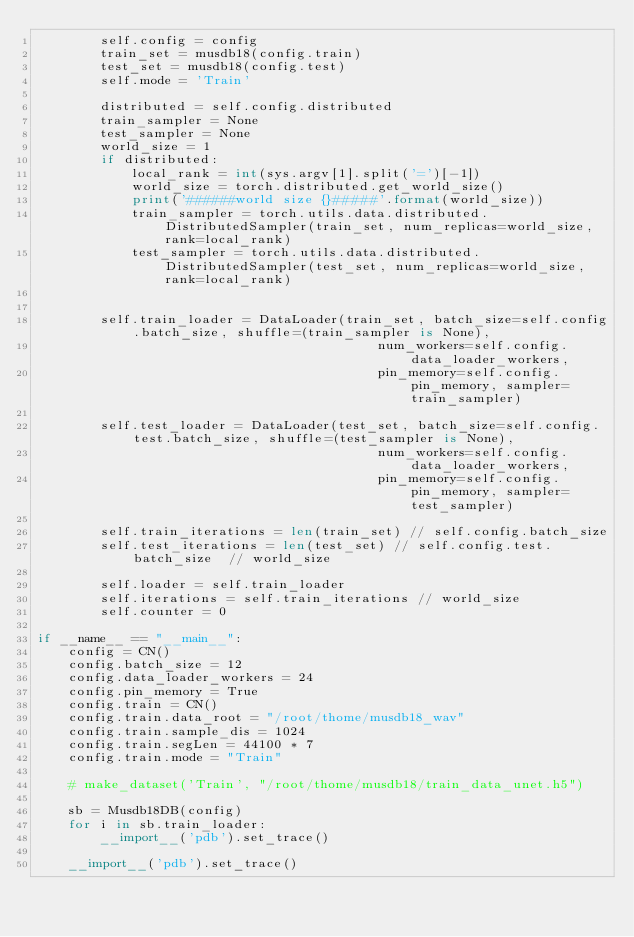Convert code to text. <code><loc_0><loc_0><loc_500><loc_500><_Python_>        self.config = config
        train_set = musdb18(config.train)
        test_set = musdb18(config.test)
        self.mode = 'Train'

        distributed = self.config.distributed
        train_sampler = None
        test_sampler = None
        world_size = 1
        if distributed:
            local_rank = int(sys.argv[1].split('=')[-1])
            world_size = torch.distributed.get_world_size()
            print('######world size {}#####'.format(world_size))
            train_sampler = torch.utils.data.distributed.DistributedSampler(train_set, num_replicas=world_size, rank=local_rank)
            test_sampler = torch.utils.data.distributed.DistributedSampler(test_set, num_replicas=world_size, rank=local_rank)


        self.train_loader = DataLoader(train_set, batch_size=self.config.batch_size, shuffle=(train_sampler is None),
                                           num_workers=self.config.data_loader_workers,
                                           pin_memory=self.config.pin_memory, sampler=train_sampler)

        self.test_loader = DataLoader(test_set, batch_size=self.config.test.batch_size, shuffle=(test_sampler is None),
                                           num_workers=self.config.data_loader_workers,
                                           pin_memory=self.config.pin_memory, sampler=test_sampler)

        self.train_iterations = len(train_set) // self.config.batch_size
        self.test_iterations = len(test_set) // self.config.test.batch_size  // world_size

        self.loader = self.train_loader
        self.iterations = self.train_iterations // world_size
        self.counter = 0

if __name__ == "__main__":
    config = CN()
    config.batch_size = 12
    config.data_loader_workers = 24
    config.pin_memory = True 
    config.train = CN()
    config.train.data_root = "/root/thome/musdb18_wav"
    config.train.sample_dis = 1024
    config.train.segLen = 44100 * 7
    config.train.mode = "Train"

    # make_dataset('Train', "/root/thome/musdb18/train_data_unet.h5")
    
    sb = Musdb18DB(config)
    for i in sb.train_loader:
        __import__('pdb').set_trace() 

    __import__('pdb').set_trace() 
</code> 